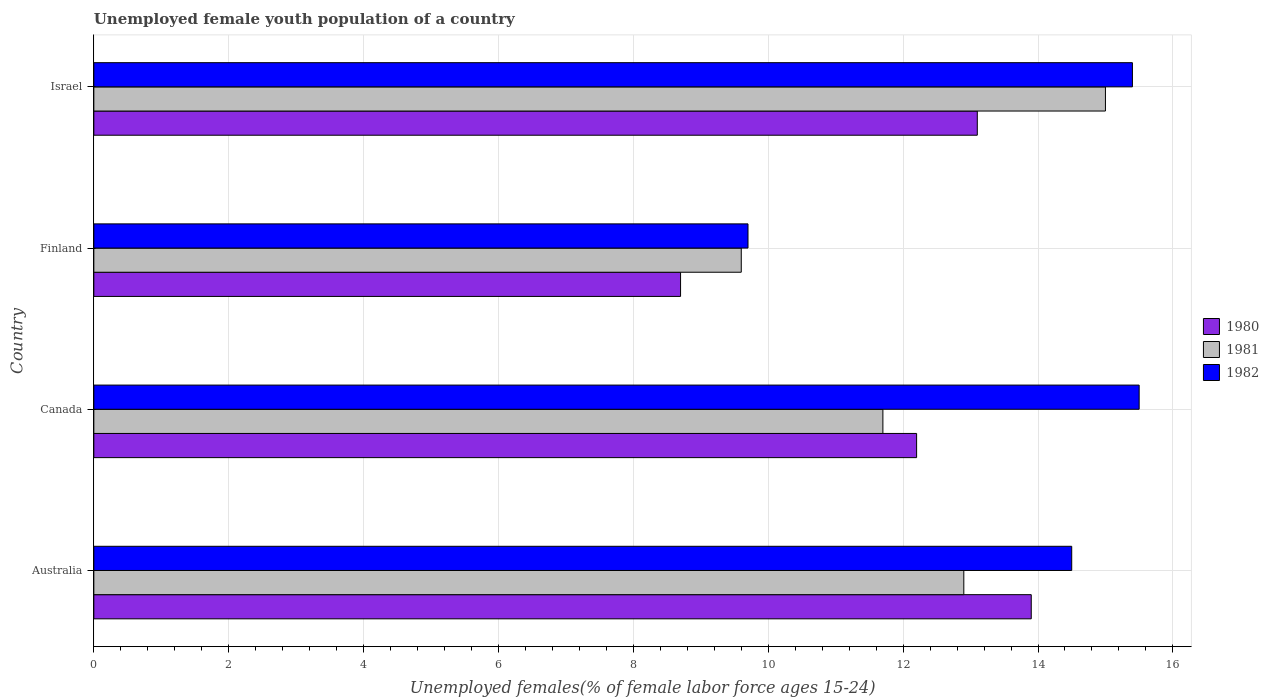How many different coloured bars are there?
Provide a succinct answer. 3. Are the number of bars per tick equal to the number of legend labels?
Provide a succinct answer. Yes. Are the number of bars on each tick of the Y-axis equal?
Your answer should be compact. Yes. How many bars are there on the 3rd tick from the bottom?
Provide a succinct answer. 3. What is the percentage of unemployed female youth population in 1981 in Finland?
Your answer should be very brief. 9.6. Across all countries, what is the maximum percentage of unemployed female youth population in 1980?
Provide a short and direct response. 13.9. Across all countries, what is the minimum percentage of unemployed female youth population in 1981?
Offer a very short reply. 9.6. What is the total percentage of unemployed female youth population in 1982 in the graph?
Keep it short and to the point. 55.1. What is the difference between the percentage of unemployed female youth population in 1981 in Australia and that in Canada?
Offer a very short reply. 1.2. What is the difference between the percentage of unemployed female youth population in 1982 in Canada and the percentage of unemployed female youth population in 1980 in Finland?
Your answer should be compact. 6.8. What is the average percentage of unemployed female youth population in 1981 per country?
Your answer should be very brief. 12.3. What is the difference between the percentage of unemployed female youth population in 1981 and percentage of unemployed female youth population in 1980 in Israel?
Your answer should be very brief. 1.9. In how many countries, is the percentage of unemployed female youth population in 1980 greater than 8.8 %?
Your response must be concise. 3. What is the ratio of the percentage of unemployed female youth population in 1982 in Canada to that in Finland?
Provide a succinct answer. 1.6. Is the percentage of unemployed female youth population in 1980 in Australia less than that in Finland?
Give a very brief answer. No. What is the difference between the highest and the second highest percentage of unemployed female youth population in 1982?
Ensure brevity in your answer.  0.1. What is the difference between the highest and the lowest percentage of unemployed female youth population in 1980?
Ensure brevity in your answer.  5.2. In how many countries, is the percentage of unemployed female youth population in 1980 greater than the average percentage of unemployed female youth population in 1980 taken over all countries?
Your answer should be compact. 3. Is it the case that in every country, the sum of the percentage of unemployed female youth population in 1980 and percentage of unemployed female youth population in 1981 is greater than the percentage of unemployed female youth population in 1982?
Your answer should be compact. Yes. How many bars are there?
Your answer should be compact. 12. Are all the bars in the graph horizontal?
Provide a succinct answer. Yes. How many countries are there in the graph?
Offer a very short reply. 4. What is the difference between two consecutive major ticks on the X-axis?
Your answer should be compact. 2. Where does the legend appear in the graph?
Offer a very short reply. Center right. What is the title of the graph?
Give a very brief answer. Unemployed female youth population of a country. Does "1985" appear as one of the legend labels in the graph?
Keep it short and to the point. No. What is the label or title of the X-axis?
Offer a terse response. Unemployed females(% of female labor force ages 15-24). What is the Unemployed females(% of female labor force ages 15-24) of 1980 in Australia?
Offer a very short reply. 13.9. What is the Unemployed females(% of female labor force ages 15-24) of 1981 in Australia?
Your answer should be compact. 12.9. What is the Unemployed females(% of female labor force ages 15-24) of 1982 in Australia?
Offer a very short reply. 14.5. What is the Unemployed females(% of female labor force ages 15-24) in 1980 in Canada?
Give a very brief answer. 12.2. What is the Unemployed females(% of female labor force ages 15-24) in 1981 in Canada?
Your answer should be compact. 11.7. What is the Unemployed females(% of female labor force ages 15-24) in 1982 in Canada?
Make the answer very short. 15.5. What is the Unemployed females(% of female labor force ages 15-24) in 1980 in Finland?
Keep it short and to the point. 8.7. What is the Unemployed females(% of female labor force ages 15-24) of 1981 in Finland?
Your answer should be very brief. 9.6. What is the Unemployed females(% of female labor force ages 15-24) of 1982 in Finland?
Your answer should be compact. 9.7. What is the Unemployed females(% of female labor force ages 15-24) of 1980 in Israel?
Give a very brief answer. 13.1. What is the Unemployed females(% of female labor force ages 15-24) in 1981 in Israel?
Provide a succinct answer. 15. What is the Unemployed females(% of female labor force ages 15-24) in 1982 in Israel?
Your response must be concise. 15.4. Across all countries, what is the maximum Unemployed females(% of female labor force ages 15-24) of 1980?
Provide a short and direct response. 13.9. Across all countries, what is the minimum Unemployed females(% of female labor force ages 15-24) in 1980?
Your response must be concise. 8.7. Across all countries, what is the minimum Unemployed females(% of female labor force ages 15-24) of 1981?
Your response must be concise. 9.6. Across all countries, what is the minimum Unemployed females(% of female labor force ages 15-24) of 1982?
Your response must be concise. 9.7. What is the total Unemployed females(% of female labor force ages 15-24) in 1980 in the graph?
Provide a succinct answer. 47.9. What is the total Unemployed females(% of female labor force ages 15-24) in 1981 in the graph?
Provide a succinct answer. 49.2. What is the total Unemployed females(% of female labor force ages 15-24) of 1982 in the graph?
Make the answer very short. 55.1. What is the difference between the Unemployed females(% of female labor force ages 15-24) in 1982 in Australia and that in Canada?
Ensure brevity in your answer.  -1. What is the difference between the Unemployed females(% of female labor force ages 15-24) of 1980 in Australia and that in Finland?
Provide a succinct answer. 5.2. What is the difference between the Unemployed females(% of female labor force ages 15-24) in 1982 in Australia and that in Israel?
Your response must be concise. -0.9. What is the difference between the Unemployed females(% of female labor force ages 15-24) in 1981 in Canada and that in Finland?
Provide a succinct answer. 2.1. What is the difference between the Unemployed females(% of female labor force ages 15-24) of 1981 in Canada and that in Israel?
Give a very brief answer. -3.3. What is the difference between the Unemployed females(% of female labor force ages 15-24) in 1982 in Canada and that in Israel?
Your response must be concise. 0.1. What is the difference between the Unemployed females(% of female labor force ages 15-24) in 1982 in Finland and that in Israel?
Keep it short and to the point. -5.7. What is the difference between the Unemployed females(% of female labor force ages 15-24) in 1980 in Australia and the Unemployed females(% of female labor force ages 15-24) in 1982 in Canada?
Offer a terse response. -1.6. What is the difference between the Unemployed females(% of female labor force ages 15-24) in 1981 in Australia and the Unemployed females(% of female labor force ages 15-24) in 1982 in Canada?
Your response must be concise. -2.6. What is the difference between the Unemployed females(% of female labor force ages 15-24) of 1980 in Australia and the Unemployed females(% of female labor force ages 15-24) of 1981 in Finland?
Provide a succinct answer. 4.3. What is the difference between the Unemployed females(% of female labor force ages 15-24) in 1981 in Australia and the Unemployed females(% of female labor force ages 15-24) in 1982 in Finland?
Offer a terse response. 3.2. What is the difference between the Unemployed females(% of female labor force ages 15-24) in 1980 in Australia and the Unemployed females(% of female labor force ages 15-24) in 1981 in Israel?
Ensure brevity in your answer.  -1.1. What is the difference between the Unemployed females(% of female labor force ages 15-24) in 1980 in Australia and the Unemployed females(% of female labor force ages 15-24) in 1982 in Israel?
Make the answer very short. -1.5. What is the difference between the Unemployed females(% of female labor force ages 15-24) of 1980 in Canada and the Unemployed females(% of female labor force ages 15-24) of 1981 in Finland?
Provide a succinct answer. 2.6. What is the difference between the Unemployed females(% of female labor force ages 15-24) of 1981 in Canada and the Unemployed females(% of female labor force ages 15-24) of 1982 in Israel?
Keep it short and to the point. -3.7. What is the difference between the Unemployed females(% of female labor force ages 15-24) in 1980 in Finland and the Unemployed females(% of female labor force ages 15-24) in 1981 in Israel?
Your answer should be very brief. -6.3. What is the difference between the Unemployed females(% of female labor force ages 15-24) in 1980 in Finland and the Unemployed females(% of female labor force ages 15-24) in 1982 in Israel?
Ensure brevity in your answer.  -6.7. What is the average Unemployed females(% of female labor force ages 15-24) of 1980 per country?
Your answer should be very brief. 11.97. What is the average Unemployed females(% of female labor force ages 15-24) in 1982 per country?
Make the answer very short. 13.78. What is the difference between the Unemployed females(% of female labor force ages 15-24) in 1980 and Unemployed females(% of female labor force ages 15-24) in 1981 in Australia?
Provide a short and direct response. 1. What is the difference between the Unemployed females(% of female labor force ages 15-24) of 1980 and Unemployed females(% of female labor force ages 15-24) of 1982 in Australia?
Your answer should be very brief. -0.6. What is the difference between the Unemployed females(% of female labor force ages 15-24) of 1981 and Unemployed females(% of female labor force ages 15-24) of 1982 in Australia?
Make the answer very short. -1.6. What is the difference between the Unemployed females(% of female labor force ages 15-24) in 1980 and Unemployed females(% of female labor force ages 15-24) in 1981 in Canada?
Keep it short and to the point. 0.5. What is the difference between the Unemployed females(% of female labor force ages 15-24) of 1981 and Unemployed females(% of female labor force ages 15-24) of 1982 in Canada?
Give a very brief answer. -3.8. What is the difference between the Unemployed females(% of female labor force ages 15-24) of 1981 and Unemployed females(% of female labor force ages 15-24) of 1982 in Finland?
Give a very brief answer. -0.1. What is the difference between the Unemployed females(% of female labor force ages 15-24) of 1980 and Unemployed females(% of female labor force ages 15-24) of 1981 in Israel?
Provide a succinct answer. -1.9. What is the difference between the Unemployed females(% of female labor force ages 15-24) in 1980 and Unemployed females(% of female labor force ages 15-24) in 1982 in Israel?
Ensure brevity in your answer.  -2.3. What is the difference between the Unemployed females(% of female labor force ages 15-24) of 1981 and Unemployed females(% of female labor force ages 15-24) of 1982 in Israel?
Give a very brief answer. -0.4. What is the ratio of the Unemployed females(% of female labor force ages 15-24) of 1980 in Australia to that in Canada?
Provide a short and direct response. 1.14. What is the ratio of the Unemployed females(% of female labor force ages 15-24) in 1981 in Australia to that in Canada?
Make the answer very short. 1.1. What is the ratio of the Unemployed females(% of female labor force ages 15-24) in 1982 in Australia to that in Canada?
Offer a terse response. 0.94. What is the ratio of the Unemployed females(% of female labor force ages 15-24) in 1980 in Australia to that in Finland?
Make the answer very short. 1.6. What is the ratio of the Unemployed females(% of female labor force ages 15-24) of 1981 in Australia to that in Finland?
Your answer should be very brief. 1.34. What is the ratio of the Unemployed females(% of female labor force ages 15-24) in 1982 in Australia to that in Finland?
Your answer should be very brief. 1.49. What is the ratio of the Unemployed females(% of female labor force ages 15-24) of 1980 in Australia to that in Israel?
Your answer should be compact. 1.06. What is the ratio of the Unemployed females(% of female labor force ages 15-24) of 1981 in Australia to that in Israel?
Offer a terse response. 0.86. What is the ratio of the Unemployed females(% of female labor force ages 15-24) of 1982 in Australia to that in Israel?
Give a very brief answer. 0.94. What is the ratio of the Unemployed females(% of female labor force ages 15-24) of 1980 in Canada to that in Finland?
Provide a succinct answer. 1.4. What is the ratio of the Unemployed females(% of female labor force ages 15-24) in 1981 in Canada to that in Finland?
Ensure brevity in your answer.  1.22. What is the ratio of the Unemployed females(% of female labor force ages 15-24) of 1982 in Canada to that in Finland?
Provide a short and direct response. 1.6. What is the ratio of the Unemployed females(% of female labor force ages 15-24) in 1980 in Canada to that in Israel?
Provide a succinct answer. 0.93. What is the ratio of the Unemployed females(% of female labor force ages 15-24) of 1981 in Canada to that in Israel?
Make the answer very short. 0.78. What is the ratio of the Unemployed females(% of female labor force ages 15-24) of 1980 in Finland to that in Israel?
Provide a succinct answer. 0.66. What is the ratio of the Unemployed females(% of female labor force ages 15-24) of 1981 in Finland to that in Israel?
Provide a succinct answer. 0.64. What is the ratio of the Unemployed females(% of female labor force ages 15-24) in 1982 in Finland to that in Israel?
Offer a very short reply. 0.63. What is the difference between the highest and the second highest Unemployed females(% of female labor force ages 15-24) in 1980?
Give a very brief answer. 0.8. What is the difference between the highest and the lowest Unemployed females(% of female labor force ages 15-24) of 1982?
Give a very brief answer. 5.8. 